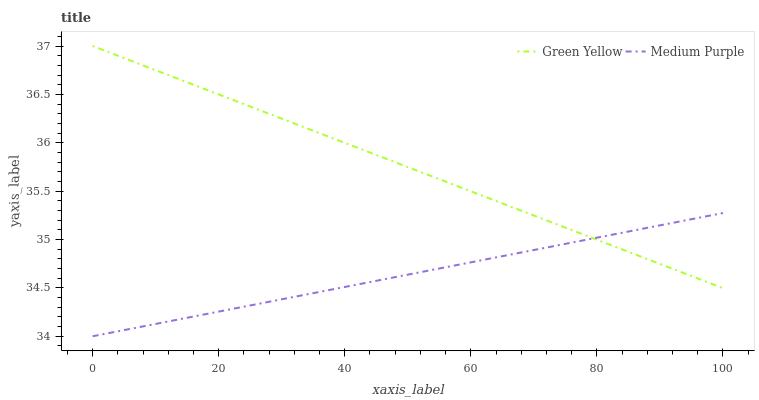Does Medium Purple have the minimum area under the curve?
Answer yes or no. Yes. Does Green Yellow have the maximum area under the curve?
Answer yes or no. Yes. Does Green Yellow have the minimum area under the curve?
Answer yes or no. No. Is Green Yellow the smoothest?
Answer yes or no. Yes. Is Medium Purple the roughest?
Answer yes or no. Yes. Is Green Yellow the roughest?
Answer yes or no. No. Does Medium Purple have the lowest value?
Answer yes or no. Yes. Does Green Yellow have the lowest value?
Answer yes or no. No. Does Green Yellow have the highest value?
Answer yes or no. Yes. Does Green Yellow intersect Medium Purple?
Answer yes or no. Yes. Is Green Yellow less than Medium Purple?
Answer yes or no. No. Is Green Yellow greater than Medium Purple?
Answer yes or no. No. 